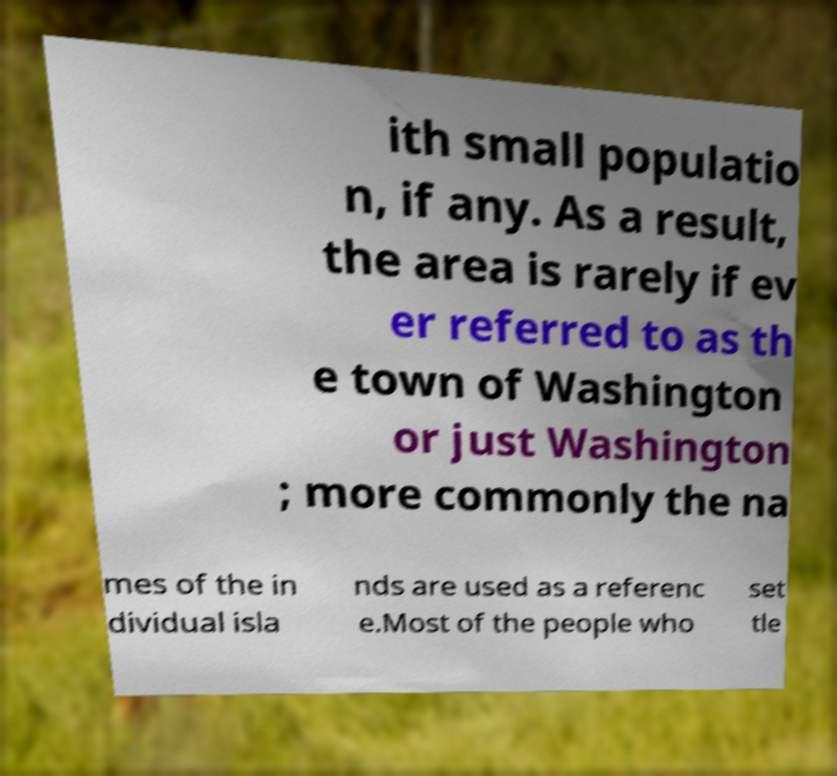There's text embedded in this image that I need extracted. Can you transcribe it verbatim? ith small populatio n, if any. As a result, the area is rarely if ev er referred to as th e town of Washington or just Washington ; more commonly the na mes of the in dividual isla nds are used as a referenc e.Most of the people who set tle 